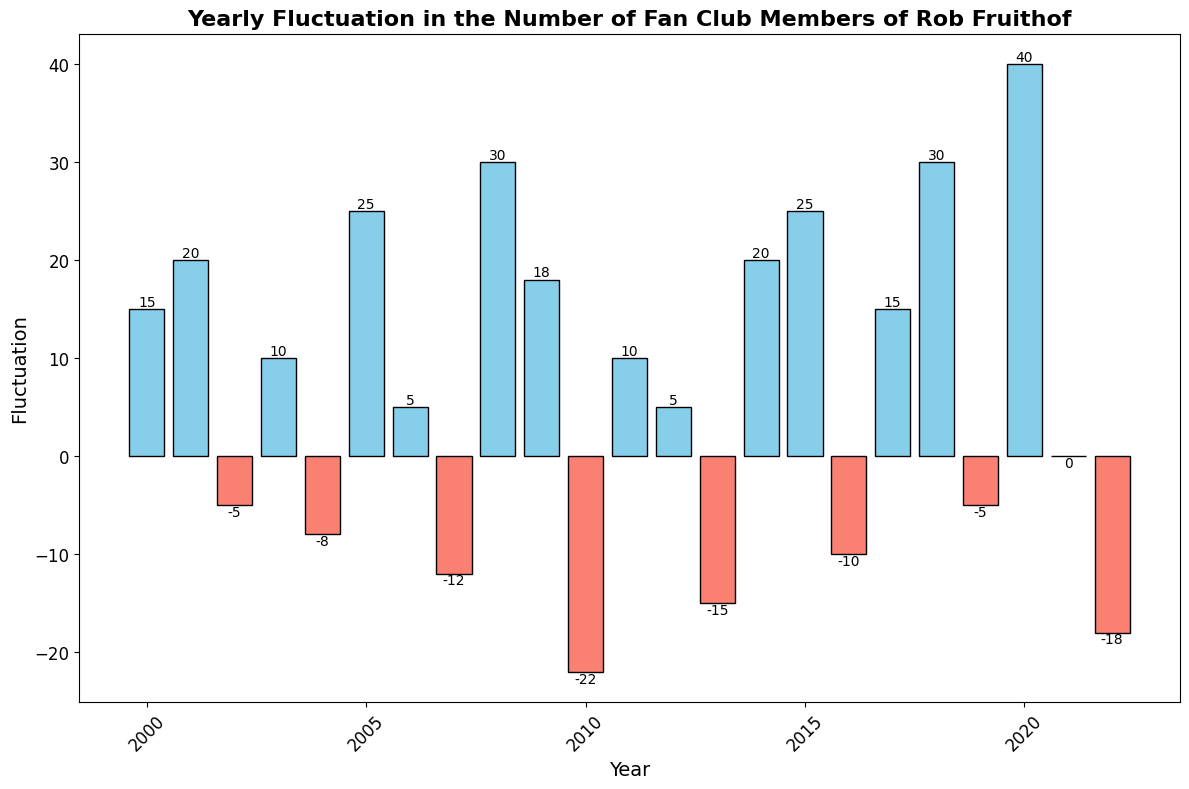Which year had the highest positive fluctuation? The bar with the highest positive value indicates the year with the highest positive fluctuation. Looking at the chart, the bar for the year 2020 is the tallest and blue, representing the highest positive fluctuation of 40.
Answer: 2020 What is the total fluctuation from 2001 to 2003? Adding the fluctuations from 2001 (20), 2002 (-5), and 2003 (10): 20 + (-5) + 10 = 25.
Answer: 25 Which year had the largest negative fluctuation? The bar with the lowest value indicates the year with the largest negative fluctuation. The bar for the year 2010 is the lowest and red, representing the largest negative fluctuation of -22.
Answer: 2010 How many years had a positive fluctuation? Count the number of blue bars in the chart. There are 13 blue bars.
Answer: 13 What is the difference in fluctuation between 2005 and 2016? Subtract the fluctuation in 2016 (-10) from the fluctuation in 2005 (25): 25 - (-10) = 35.
Answer: 35 Which years had zero fluctuation? Identify the bars with a height of zero. The year 2021 had zero fluctuation.
Answer: 2021 What is the average fluctuation from 2018 to 2020? Calculate the average by adding the fluctuations for 2018 (30), 2019 (-5), and 2020 (40) and dividing by 3: (30 - 5 + 40) / 3 = 65 / 3 ≈ 21.67.
Answer: 21.67 What is the cumulative fluctuation over the entire period from 2000 to 2022? Sum all the fluctuations from 2000 to 2022: 15 + 20 - 5 + 10 - 8 + 25 + 5 - 12 + 30 + 18 - 22 + 10 + 5 - 15 + 20 + 25 - 10 + 15 + 30 - 5 + 40 + 0 - 18 = 218.
Answer: 218 Which year had a higher fluctuation, 2011 or 2014? Compare the heights of the bars for 2011 (10) and 2014 (20). 2014 had a higher positive fluctuation.
Answer: 2014 What is the range of the fluctuations in the given data? The range is calculated by subtracting the smallest fluctuation (-22 in 2010) from the largest fluctuation (40 in 2020): 40 - (-22) = 62.
Answer: 62 